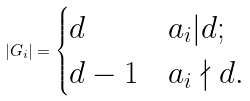Convert formula to latex. <formula><loc_0><loc_0><loc_500><loc_500>| G _ { i } | = \begin{cases} d & a _ { i } | d ; \\ d - 1 & a _ { i } \nmid d . \end{cases}</formula> 